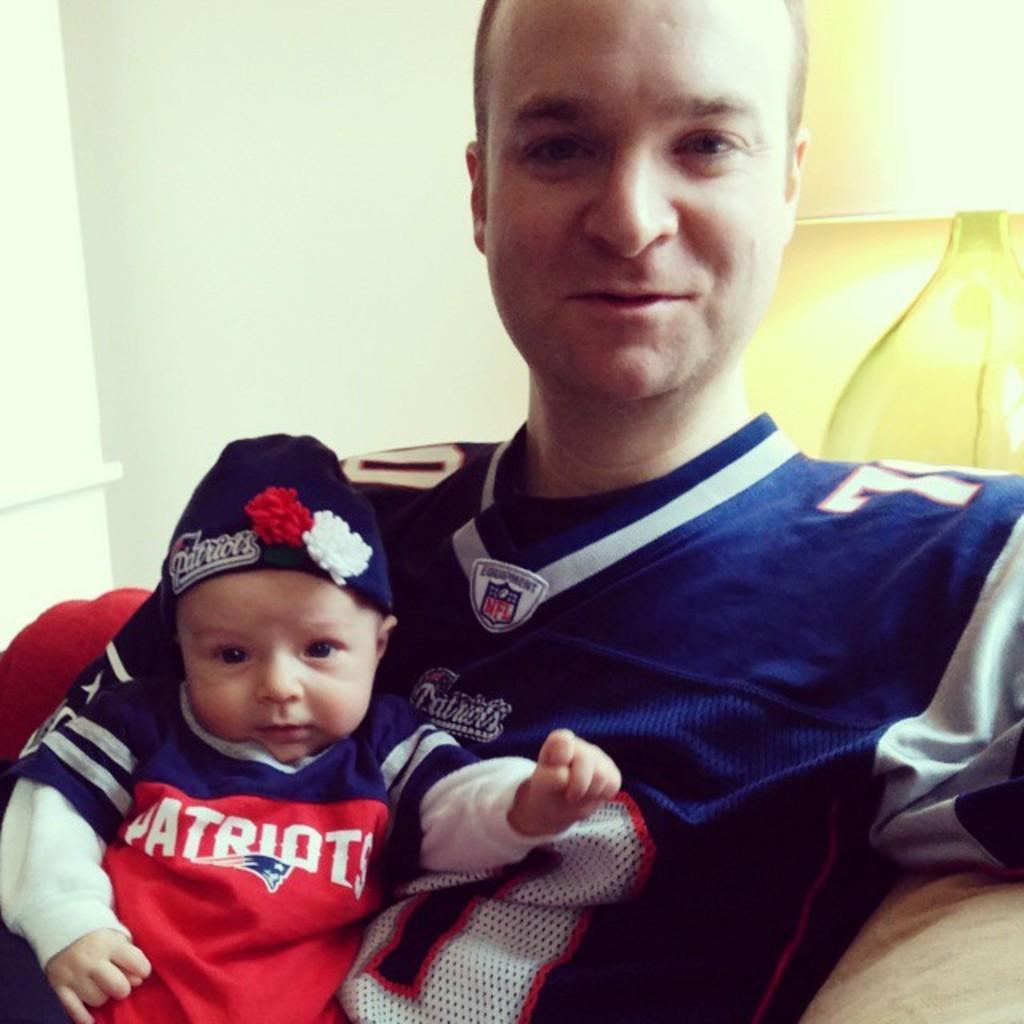<image>
Give a short and clear explanation of the subsequent image. A man and his baby are dressed in Patriots jerseys. 